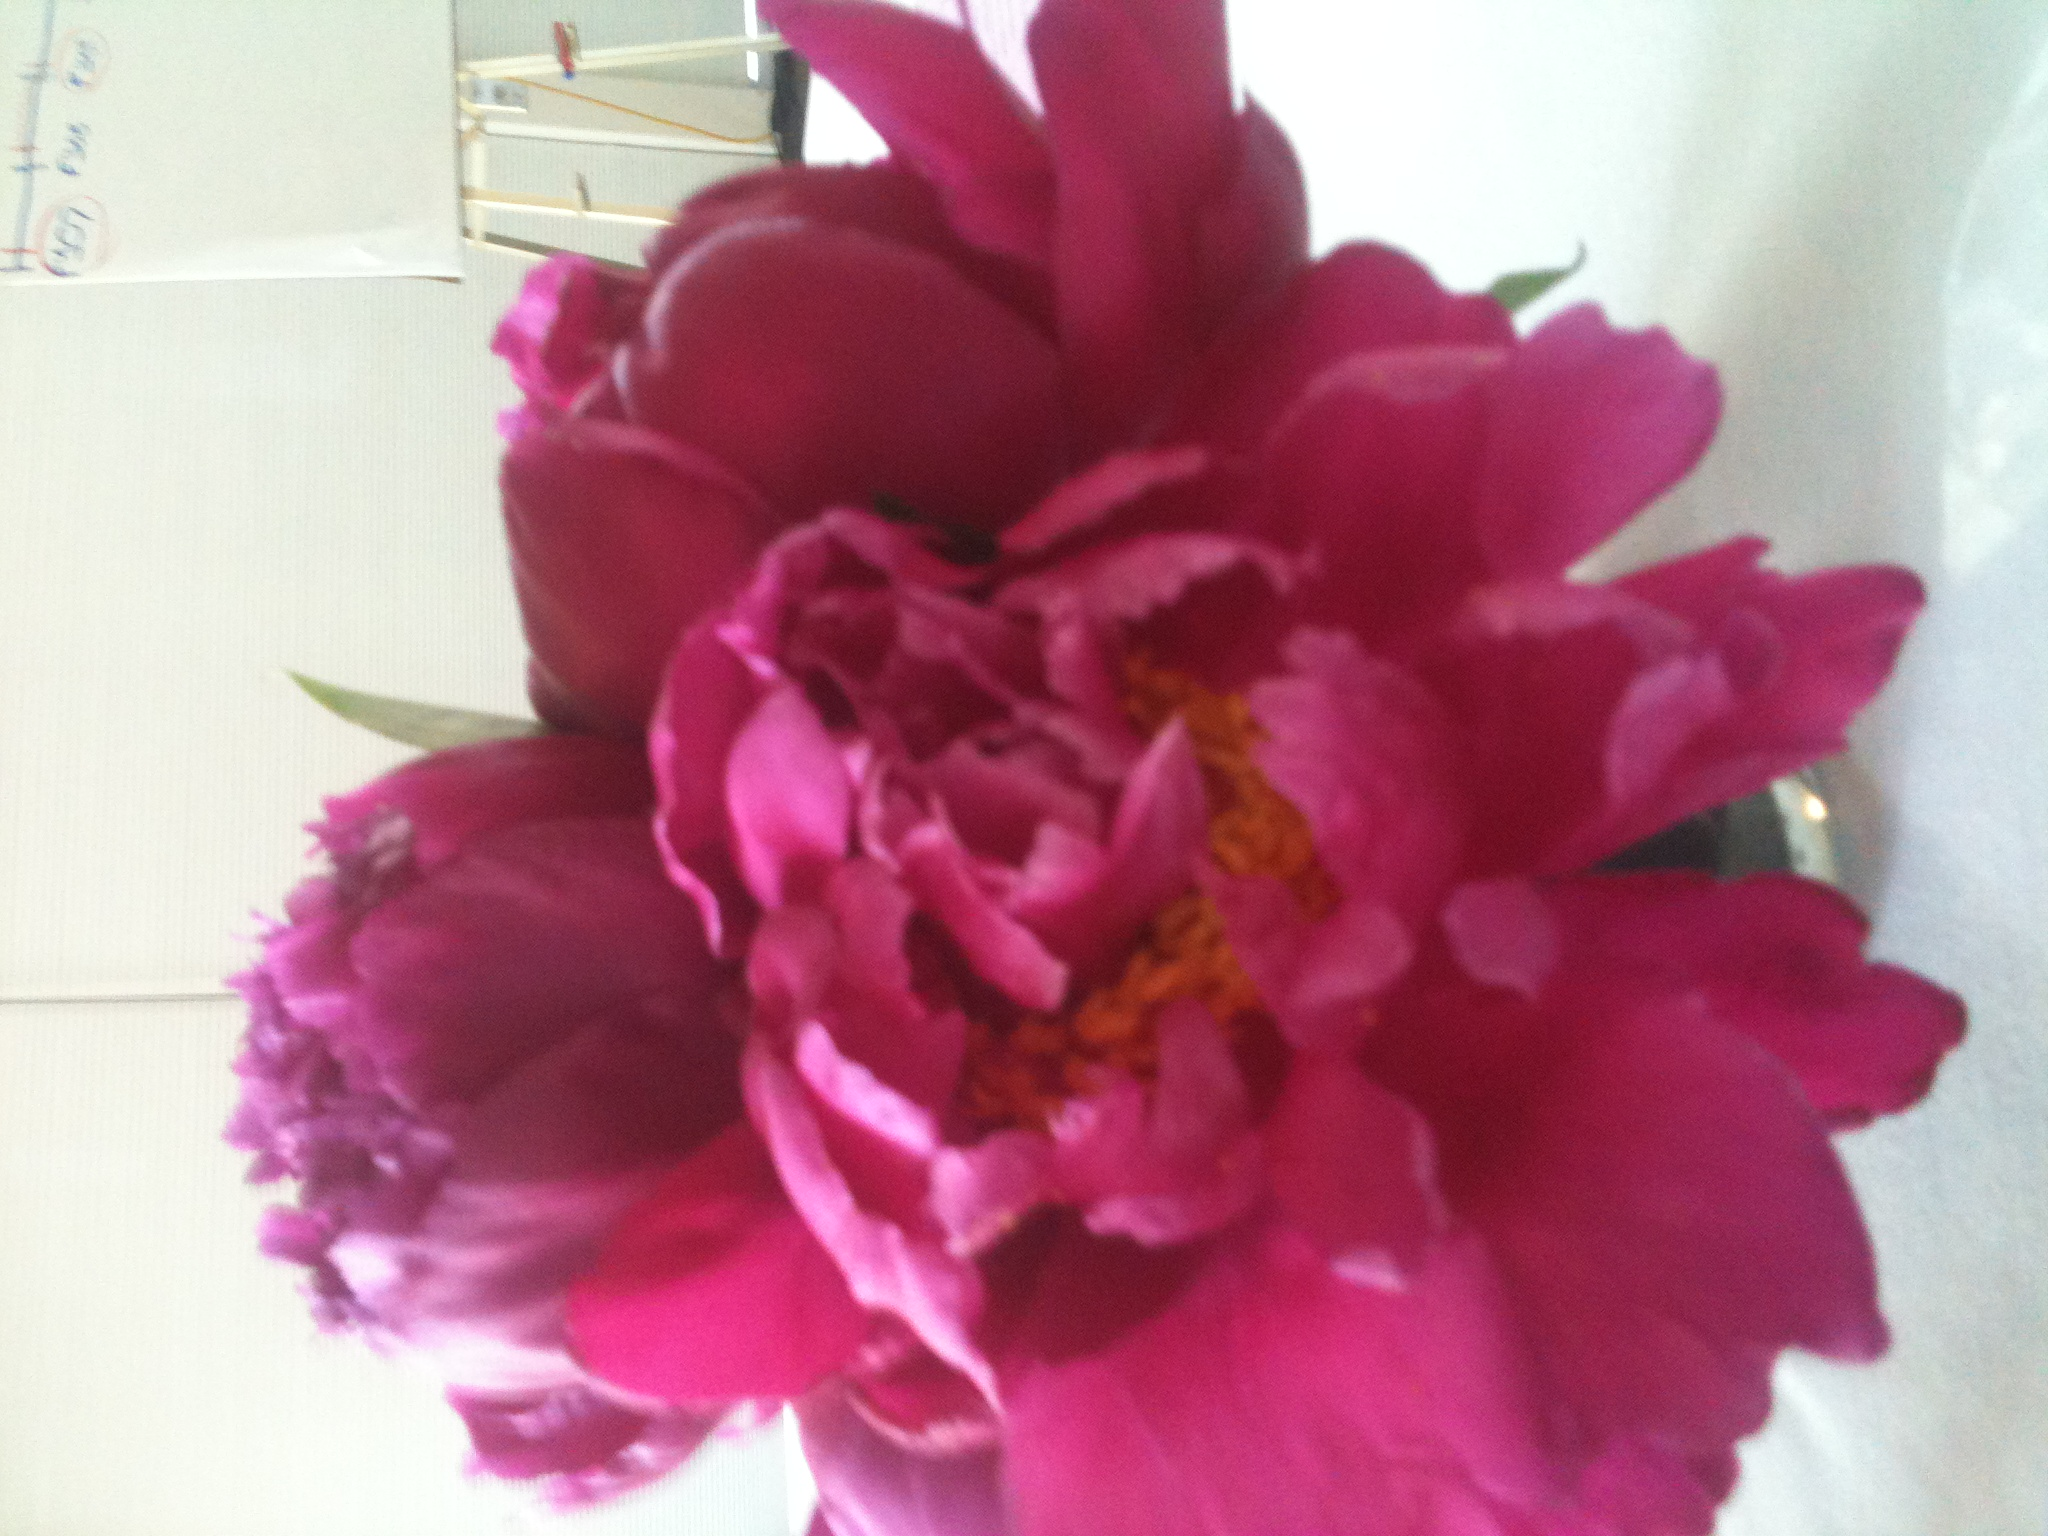Can you describe the flower in terms of its potential uses and significance in different cultures? Certainly! The flower in the image appears to be a peony, a flower cherished in many cultures for its beauty and symbolism. In Chinese culture, peonies are often called the 'king of flowers' and symbolize wealth, honor, and prosperity. They are frequently used in weddings and festive decorations. In Western cultures, peonies are popular in bouquets, centerpieces, and gardening due to their large, aromatic blooms. They can also be dried and used in potpourri or as decoration for craft projects. What are some common ways people care for and maintain these flowers in a garden? Peonies are relatively low-maintenance but do require some specific care to thrive. Here are some tips for maintaining peonies in a garden:
1. **Location:** Plant peonies in a spot that receives at least six hours of full sun per day.
2. **Soil:** They prefer well-drained soil enriched with compost or well-rotted manure.
3. **Planting Depth:** Ensure the root crown is no more than 1-2 inches below the soil surface, as too deep planting can prevent blooming.
4. **Watering:** Regular watering is essential, especially during dry spells, but avoid waterlogging.
5. **Support:** Use stakes or cages to support the heavy blooms and prevent the stems from drooping.
6. **Pruning:** Cut back the foliage in the fall after it has died down to prevent disease.
7. **Winter Care:** Apply a mulch layer in colder climates to protect the roots from freezing. Can you imagine a fantastical story involving this flower? In a mystical land far beyond the visible sky, there bloomed a garden where each peony held magical powers. Legend spoke of a unique pink peony, whose petals glowed under the moonlight and contained the secrets of eternal wisdom. Many brave souls ventured into the garden to find this enchanted flower, crossing enchanted fields and talking rivers. One day, a humble gardener named Elara discovered the pink peony. However, rather than plucking it for herself, she sang to it. The flower whispered stories of ancient times, imparting wisdom about nature and the harmony of life. Elara shared these stories with her village, bringing prosperity and peace to her people. It was said that the glow of the magical peony never dimmed, and its essence lived on in every bloom that graced the land. 